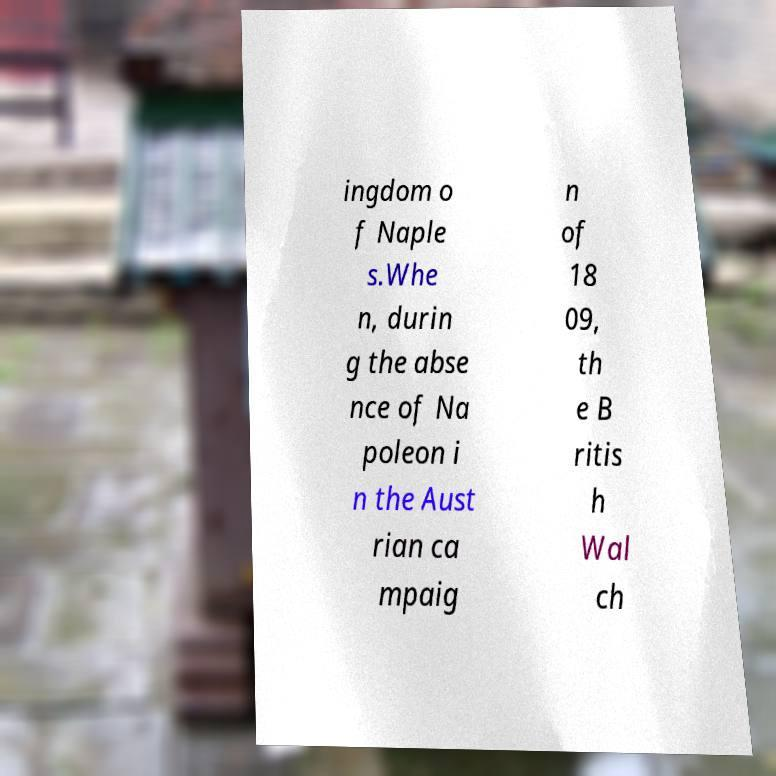Could you extract and type out the text from this image? ingdom o f Naple s.Whe n, durin g the abse nce of Na poleon i n the Aust rian ca mpaig n of 18 09, th e B ritis h Wal ch 